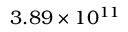<formula> <loc_0><loc_0><loc_500><loc_500>3 . 8 9 \times 1 0 ^ { 1 1 }</formula> 